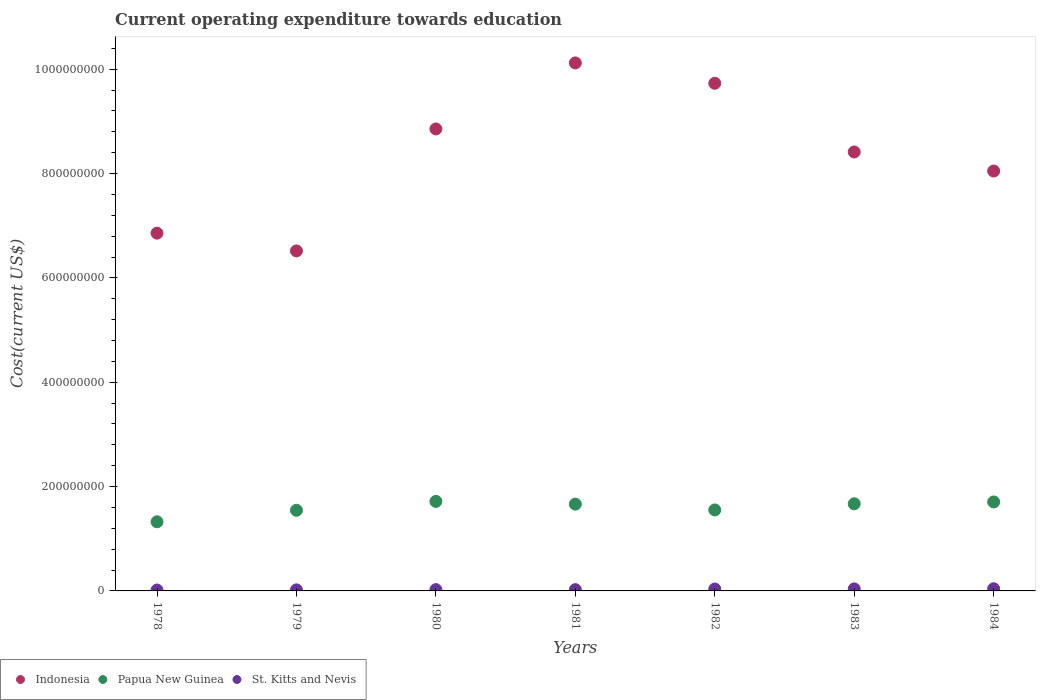Is the number of dotlines equal to the number of legend labels?
Give a very brief answer. Yes. What is the expenditure towards education in Papua New Guinea in 1981?
Your answer should be compact. 1.66e+08. Across all years, what is the maximum expenditure towards education in St. Kitts and Nevis?
Your answer should be very brief. 4.14e+06. Across all years, what is the minimum expenditure towards education in Indonesia?
Your answer should be compact. 6.52e+08. In which year was the expenditure towards education in Indonesia minimum?
Offer a terse response. 1979. What is the total expenditure towards education in St. Kitts and Nevis in the graph?
Make the answer very short. 2.03e+07. What is the difference between the expenditure towards education in Indonesia in 1980 and that in 1981?
Offer a very short reply. -1.27e+08. What is the difference between the expenditure towards education in Indonesia in 1981 and the expenditure towards education in Papua New Guinea in 1980?
Offer a very short reply. 8.40e+08. What is the average expenditure towards education in St. Kitts and Nevis per year?
Offer a very short reply. 2.90e+06. In the year 1980, what is the difference between the expenditure towards education in Papua New Guinea and expenditure towards education in Indonesia?
Give a very brief answer. -7.14e+08. In how many years, is the expenditure towards education in Papua New Guinea greater than 920000000 US$?
Offer a terse response. 0. What is the ratio of the expenditure towards education in St. Kitts and Nevis in 1980 to that in 1982?
Provide a succinct answer. 0.67. What is the difference between the highest and the second highest expenditure towards education in St. Kitts and Nevis?
Provide a short and direct response. 2.55e+05. What is the difference between the highest and the lowest expenditure towards education in Papua New Guinea?
Offer a very short reply. 3.90e+07. Is the sum of the expenditure towards education in St. Kitts and Nevis in 1980 and 1982 greater than the maximum expenditure towards education in Papua New Guinea across all years?
Offer a very short reply. No. Is it the case that in every year, the sum of the expenditure towards education in Papua New Guinea and expenditure towards education in St. Kitts and Nevis  is greater than the expenditure towards education in Indonesia?
Your response must be concise. No. Is the expenditure towards education in Indonesia strictly less than the expenditure towards education in Papua New Guinea over the years?
Provide a short and direct response. No. How many years are there in the graph?
Keep it short and to the point. 7. How are the legend labels stacked?
Offer a very short reply. Horizontal. What is the title of the graph?
Your response must be concise. Current operating expenditure towards education. Does "Cayman Islands" appear as one of the legend labels in the graph?
Give a very brief answer. No. What is the label or title of the Y-axis?
Keep it short and to the point. Cost(current US$). What is the Cost(current US$) in Indonesia in 1978?
Give a very brief answer. 6.86e+08. What is the Cost(current US$) in Papua New Guinea in 1978?
Offer a terse response. 1.33e+08. What is the Cost(current US$) of St. Kitts and Nevis in 1978?
Give a very brief answer. 1.71e+06. What is the Cost(current US$) in Indonesia in 1979?
Offer a very short reply. 6.52e+08. What is the Cost(current US$) of Papua New Guinea in 1979?
Give a very brief answer. 1.55e+08. What is the Cost(current US$) in St. Kitts and Nevis in 1979?
Keep it short and to the point. 2.01e+06. What is the Cost(current US$) in Indonesia in 1980?
Offer a terse response. 8.85e+08. What is the Cost(current US$) in Papua New Guinea in 1980?
Make the answer very short. 1.72e+08. What is the Cost(current US$) in St. Kitts and Nevis in 1980?
Keep it short and to the point. 2.43e+06. What is the Cost(current US$) in Indonesia in 1981?
Offer a very short reply. 1.01e+09. What is the Cost(current US$) in Papua New Guinea in 1981?
Offer a very short reply. 1.66e+08. What is the Cost(current US$) in St. Kitts and Nevis in 1981?
Make the answer very short. 2.47e+06. What is the Cost(current US$) in Indonesia in 1982?
Make the answer very short. 9.73e+08. What is the Cost(current US$) in Papua New Guinea in 1982?
Provide a succinct answer. 1.55e+08. What is the Cost(current US$) of St. Kitts and Nevis in 1982?
Keep it short and to the point. 3.64e+06. What is the Cost(current US$) in Indonesia in 1983?
Provide a succinct answer. 8.41e+08. What is the Cost(current US$) in Papua New Guinea in 1983?
Offer a very short reply. 1.67e+08. What is the Cost(current US$) of St. Kitts and Nevis in 1983?
Offer a terse response. 3.88e+06. What is the Cost(current US$) of Indonesia in 1984?
Give a very brief answer. 8.05e+08. What is the Cost(current US$) of Papua New Guinea in 1984?
Your answer should be compact. 1.71e+08. What is the Cost(current US$) of St. Kitts and Nevis in 1984?
Give a very brief answer. 4.14e+06. Across all years, what is the maximum Cost(current US$) in Indonesia?
Your answer should be compact. 1.01e+09. Across all years, what is the maximum Cost(current US$) in Papua New Guinea?
Make the answer very short. 1.72e+08. Across all years, what is the maximum Cost(current US$) of St. Kitts and Nevis?
Provide a succinct answer. 4.14e+06. Across all years, what is the minimum Cost(current US$) of Indonesia?
Offer a terse response. 6.52e+08. Across all years, what is the minimum Cost(current US$) of Papua New Guinea?
Give a very brief answer. 1.33e+08. Across all years, what is the minimum Cost(current US$) in St. Kitts and Nevis?
Offer a very short reply. 1.71e+06. What is the total Cost(current US$) of Indonesia in the graph?
Offer a terse response. 5.85e+09. What is the total Cost(current US$) in Papua New Guinea in the graph?
Give a very brief answer. 1.12e+09. What is the total Cost(current US$) in St. Kitts and Nevis in the graph?
Ensure brevity in your answer.  2.03e+07. What is the difference between the Cost(current US$) in Indonesia in 1978 and that in 1979?
Make the answer very short. 3.40e+07. What is the difference between the Cost(current US$) of Papua New Guinea in 1978 and that in 1979?
Ensure brevity in your answer.  -2.21e+07. What is the difference between the Cost(current US$) in St. Kitts and Nevis in 1978 and that in 1979?
Make the answer very short. -2.93e+05. What is the difference between the Cost(current US$) of Indonesia in 1978 and that in 1980?
Keep it short and to the point. -2.00e+08. What is the difference between the Cost(current US$) in Papua New Guinea in 1978 and that in 1980?
Provide a short and direct response. -3.90e+07. What is the difference between the Cost(current US$) of St. Kitts and Nevis in 1978 and that in 1980?
Make the answer very short. -7.20e+05. What is the difference between the Cost(current US$) in Indonesia in 1978 and that in 1981?
Keep it short and to the point. -3.26e+08. What is the difference between the Cost(current US$) of Papua New Guinea in 1978 and that in 1981?
Your answer should be compact. -3.38e+07. What is the difference between the Cost(current US$) in St. Kitts and Nevis in 1978 and that in 1981?
Offer a terse response. -7.57e+05. What is the difference between the Cost(current US$) in Indonesia in 1978 and that in 1982?
Offer a terse response. -2.87e+08. What is the difference between the Cost(current US$) of Papua New Guinea in 1978 and that in 1982?
Offer a terse response. -2.27e+07. What is the difference between the Cost(current US$) in St. Kitts and Nevis in 1978 and that in 1982?
Make the answer very short. -1.92e+06. What is the difference between the Cost(current US$) in Indonesia in 1978 and that in 1983?
Offer a very short reply. -1.56e+08. What is the difference between the Cost(current US$) in Papua New Guinea in 1978 and that in 1983?
Keep it short and to the point. -3.44e+07. What is the difference between the Cost(current US$) of St. Kitts and Nevis in 1978 and that in 1983?
Offer a very short reply. -2.17e+06. What is the difference between the Cost(current US$) in Indonesia in 1978 and that in 1984?
Offer a very short reply. -1.19e+08. What is the difference between the Cost(current US$) of Papua New Guinea in 1978 and that in 1984?
Your answer should be compact. -3.80e+07. What is the difference between the Cost(current US$) in St. Kitts and Nevis in 1978 and that in 1984?
Give a very brief answer. -2.42e+06. What is the difference between the Cost(current US$) in Indonesia in 1979 and that in 1980?
Give a very brief answer. -2.34e+08. What is the difference between the Cost(current US$) in Papua New Guinea in 1979 and that in 1980?
Offer a terse response. -1.70e+07. What is the difference between the Cost(current US$) of St. Kitts and Nevis in 1979 and that in 1980?
Give a very brief answer. -4.27e+05. What is the difference between the Cost(current US$) in Indonesia in 1979 and that in 1981?
Give a very brief answer. -3.60e+08. What is the difference between the Cost(current US$) in Papua New Guinea in 1979 and that in 1981?
Your response must be concise. -1.18e+07. What is the difference between the Cost(current US$) of St. Kitts and Nevis in 1979 and that in 1981?
Offer a terse response. -4.64e+05. What is the difference between the Cost(current US$) in Indonesia in 1979 and that in 1982?
Ensure brevity in your answer.  -3.21e+08. What is the difference between the Cost(current US$) of Papua New Guinea in 1979 and that in 1982?
Provide a succinct answer. -6.25e+05. What is the difference between the Cost(current US$) in St. Kitts and Nevis in 1979 and that in 1982?
Provide a short and direct response. -1.63e+06. What is the difference between the Cost(current US$) in Indonesia in 1979 and that in 1983?
Provide a short and direct response. -1.90e+08. What is the difference between the Cost(current US$) of Papua New Guinea in 1979 and that in 1983?
Provide a succinct answer. -1.24e+07. What is the difference between the Cost(current US$) in St. Kitts and Nevis in 1979 and that in 1983?
Your answer should be compact. -1.88e+06. What is the difference between the Cost(current US$) in Indonesia in 1979 and that in 1984?
Your answer should be compact. -1.53e+08. What is the difference between the Cost(current US$) of Papua New Guinea in 1979 and that in 1984?
Your answer should be very brief. -1.60e+07. What is the difference between the Cost(current US$) of St. Kitts and Nevis in 1979 and that in 1984?
Ensure brevity in your answer.  -2.13e+06. What is the difference between the Cost(current US$) of Indonesia in 1980 and that in 1981?
Your response must be concise. -1.27e+08. What is the difference between the Cost(current US$) in Papua New Guinea in 1980 and that in 1981?
Your response must be concise. 5.20e+06. What is the difference between the Cost(current US$) of St. Kitts and Nevis in 1980 and that in 1981?
Provide a short and direct response. -3.70e+04. What is the difference between the Cost(current US$) in Indonesia in 1980 and that in 1982?
Your answer should be compact. -8.75e+07. What is the difference between the Cost(current US$) in Papua New Guinea in 1980 and that in 1982?
Keep it short and to the point. 1.63e+07. What is the difference between the Cost(current US$) of St. Kitts and Nevis in 1980 and that in 1982?
Your response must be concise. -1.20e+06. What is the difference between the Cost(current US$) in Indonesia in 1980 and that in 1983?
Give a very brief answer. 4.41e+07. What is the difference between the Cost(current US$) in Papua New Guinea in 1980 and that in 1983?
Make the answer very short. 4.58e+06. What is the difference between the Cost(current US$) in St. Kitts and Nevis in 1980 and that in 1983?
Provide a short and direct response. -1.45e+06. What is the difference between the Cost(current US$) in Indonesia in 1980 and that in 1984?
Make the answer very short. 8.07e+07. What is the difference between the Cost(current US$) of Papua New Guinea in 1980 and that in 1984?
Your answer should be compact. 1.01e+06. What is the difference between the Cost(current US$) in St. Kitts and Nevis in 1980 and that in 1984?
Make the answer very short. -1.70e+06. What is the difference between the Cost(current US$) in Indonesia in 1981 and that in 1982?
Ensure brevity in your answer.  3.90e+07. What is the difference between the Cost(current US$) in Papua New Guinea in 1981 and that in 1982?
Offer a terse response. 1.11e+07. What is the difference between the Cost(current US$) in St. Kitts and Nevis in 1981 and that in 1982?
Provide a succinct answer. -1.17e+06. What is the difference between the Cost(current US$) in Indonesia in 1981 and that in 1983?
Provide a short and direct response. 1.71e+08. What is the difference between the Cost(current US$) in Papua New Guinea in 1981 and that in 1983?
Your response must be concise. -6.18e+05. What is the difference between the Cost(current US$) in St. Kitts and Nevis in 1981 and that in 1983?
Keep it short and to the point. -1.41e+06. What is the difference between the Cost(current US$) in Indonesia in 1981 and that in 1984?
Offer a terse response. 2.07e+08. What is the difference between the Cost(current US$) in Papua New Guinea in 1981 and that in 1984?
Your answer should be very brief. -4.19e+06. What is the difference between the Cost(current US$) of St. Kitts and Nevis in 1981 and that in 1984?
Offer a terse response. -1.67e+06. What is the difference between the Cost(current US$) of Indonesia in 1982 and that in 1983?
Make the answer very short. 1.32e+08. What is the difference between the Cost(current US$) in Papua New Guinea in 1982 and that in 1983?
Offer a terse response. -1.18e+07. What is the difference between the Cost(current US$) of St. Kitts and Nevis in 1982 and that in 1983?
Ensure brevity in your answer.  -2.45e+05. What is the difference between the Cost(current US$) of Indonesia in 1982 and that in 1984?
Provide a succinct answer. 1.68e+08. What is the difference between the Cost(current US$) in Papua New Guinea in 1982 and that in 1984?
Your response must be concise. -1.53e+07. What is the difference between the Cost(current US$) of St. Kitts and Nevis in 1982 and that in 1984?
Give a very brief answer. -5.01e+05. What is the difference between the Cost(current US$) in Indonesia in 1983 and that in 1984?
Keep it short and to the point. 3.65e+07. What is the difference between the Cost(current US$) in Papua New Guinea in 1983 and that in 1984?
Provide a succinct answer. -3.57e+06. What is the difference between the Cost(current US$) in St. Kitts and Nevis in 1983 and that in 1984?
Offer a very short reply. -2.55e+05. What is the difference between the Cost(current US$) in Indonesia in 1978 and the Cost(current US$) in Papua New Guinea in 1979?
Your response must be concise. 5.31e+08. What is the difference between the Cost(current US$) in Indonesia in 1978 and the Cost(current US$) in St. Kitts and Nevis in 1979?
Offer a terse response. 6.84e+08. What is the difference between the Cost(current US$) in Papua New Guinea in 1978 and the Cost(current US$) in St. Kitts and Nevis in 1979?
Your response must be concise. 1.31e+08. What is the difference between the Cost(current US$) in Indonesia in 1978 and the Cost(current US$) in Papua New Guinea in 1980?
Offer a very short reply. 5.14e+08. What is the difference between the Cost(current US$) in Indonesia in 1978 and the Cost(current US$) in St. Kitts and Nevis in 1980?
Offer a very short reply. 6.83e+08. What is the difference between the Cost(current US$) in Papua New Guinea in 1978 and the Cost(current US$) in St. Kitts and Nevis in 1980?
Offer a very short reply. 1.30e+08. What is the difference between the Cost(current US$) of Indonesia in 1978 and the Cost(current US$) of Papua New Guinea in 1981?
Offer a terse response. 5.19e+08. What is the difference between the Cost(current US$) in Indonesia in 1978 and the Cost(current US$) in St. Kitts and Nevis in 1981?
Offer a very short reply. 6.83e+08. What is the difference between the Cost(current US$) of Papua New Guinea in 1978 and the Cost(current US$) of St. Kitts and Nevis in 1981?
Your answer should be very brief. 1.30e+08. What is the difference between the Cost(current US$) of Indonesia in 1978 and the Cost(current US$) of Papua New Guinea in 1982?
Offer a terse response. 5.31e+08. What is the difference between the Cost(current US$) in Indonesia in 1978 and the Cost(current US$) in St. Kitts and Nevis in 1982?
Keep it short and to the point. 6.82e+08. What is the difference between the Cost(current US$) of Papua New Guinea in 1978 and the Cost(current US$) of St. Kitts and Nevis in 1982?
Provide a short and direct response. 1.29e+08. What is the difference between the Cost(current US$) in Indonesia in 1978 and the Cost(current US$) in Papua New Guinea in 1983?
Give a very brief answer. 5.19e+08. What is the difference between the Cost(current US$) of Indonesia in 1978 and the Cost(current US$) of St. Kitts and Nevis in 1983?
Provide a short and direct response. 6.82e+08. What is the difference between the Cost(current US$) in Papua New Guinea in 1978 and the Cost(current US$) in St. Kitts and Nevis in 1983?
Offer a very short reply. 1.29e+08. What is the difference between the Cost(current US$) of Indonesia in 1978 and the Cost(current US$) of Papua New Guinea in 1984?
Give a very brief answer. 5.15e+08. What is the difference between the Cost(current US$) in Indonesia in 1978 and the Cost(current US$) in St. Kitts and Nevis in 1984?
Your response must be concise. 6.82e+08. What is the difference between the Cost(current US$) of Papua New Guinea in 1978 and the Cost(current US$) of St. Kitts and Nevis in 1984?
Provide a short and direct response. 1.28e+08. What is the difference between the Cost(current US$) of Indonesia in 1979 and the Cost(current US$) of Papua New Guinea in 1980?
Your answer should be very brief. 4.80e+08. What is the difference between the Cost(current US$) in Indonesia in 1979 and the Cost(current US$) in St. Kitts and Nevis in 1980?
Provide a short and direct response. 6.49e+08. What is the difference between the Cost(current US$) of Papua New Guinea in 1979 and the Cost(current US$) of St. Kitts and Nevis in 1980?
Provide a short and direct response. 1.52e+08. What is the difference between the Cost(current US$) of Indonesia in 1979 and the Cost(current US$) of Papua New Guinea in 1981?
Your answer should be compact. 4.85e+08. What is the difference between the Cost(current US$) in Indonesia in 1979 and the Cost(current US$) in St. Kitts and Nevis in 1981?
Give a very brief answer. 6.49e+08. What is the difference between the Cost(current US$) in Papua New Guinea in 1979 and the Cost(current US$) in St. Kitts and Nevis in 1981?
Offer a terse response. 1.52e+08. What is the difference between the Cost(current US$) of Indonesia in 1979 and the Cost(current US$) of Papua New Guinea in 1982?
Keep it short and to the point. 4.97e+08. What is the difference between the Cost(current US$) of Indonesia in 1979 and the Cost(current US$) of St. Kitts and Nevis in 1982?
Make the answer very short. 6.48e+08. What is the difference between the Cost(current US$) in Papua New Guinea in 1979 and the Cost(current US$) in St. Kitts and Nevis in 1982?
Provide a short and direct response. 1.51e+08. What is the difference between the Cost(current US$) of Indonesia in 1979 and the Cost(current US$) of Papua New Guinea in 1983?
Offer a terse response. 4.85e+08. What is the difference between the Cost(current US$) in Indonesia in 1979 and the Cost(current US$) in St. Kitts and Nevis in 1983?
Offer a terse response. 6.48e+08. What is the difference between the Cost(current US$) in Papua New Guinea in 1979 and the Cost(current US$) in St. Kitts and Nevis in 1983?
Offer a very short reply. 1.51e+08. What is the difference between the Cost(current US$) in Indonesia in 1979 and the Cost(current US$) in Papua New Guinea in 1984?
Ensure brevity in your answer.  4.81e+08. What is the difference between the Cost(current US$) of Indonesia in 1979 and the Cost(current US$) of St. Kitts and Nevis in 1984?
Your response must be concise. 6.48e+08. What is the difference between the Cost(current US$) in Papua New Guinea in 1979 and the Cost(current US$) in St. Kitts and Nevis in 1984?
Your response must be concise. 1.50e+08. What is the difference between the Cost(current US$) in Indonesia in 1980 and the Cost(current US$) in Papua New Guinea in 1981?
Offer a terse response. 7.19e+08. What is the difference between the Cost(current US$) in Indonesia in 1980 and the Cost(current US$) in St. Kitts and Nevis in 1981?
Ensure brevity in your answer.  8.83e+08. What is the difference between the Cost(current US$) in Papua New Guinea in 1980 and the Cost(current US$) in St. Kitts and Nevis in 1981?
Provide a short and direct response. 1.69e+08. What is the difference between the Cost(current US$) of Indonesia in 1980 and the Cost(current US$) of Papua New Guinea in 1982?
Ensure brevity in your answer.  7.30e+08. What is the difference between the Cost(current US$) of Indonesia in 1980 and the Cost(current US$) of St. Kitts and Nevis in 1982?
Make the answer very short. 8.82e+08. What is the difference between the Cost(current US$) of Papua New Guinea in 1980 and the Cost(current US$) of St. Kitts and Nevis in 1982?
Offer a very short reply. 1.68e+08. What is the difference between the Cost(current US$) of Indonesia in 1980 and the Cost(current US$) of Papua New Guinea in 1983?
Your answer should be compact. 7.18e+08. What is the difference between the Cost(current US$) of Indonesia in 1980 and the Cost(current US$) of St. Kitts and Nevis in 1983?
Your answer should be very brief. 8.82e+08. What is the difference between the Cost(current US$) in Papua New Guinea in 1980 and the Cost(current US$) in St. Kitts and Nevis in 1983?
Keep it short and to the point. 1.68e+08. What is the difference between the Cost(current US$) in Indonesia in 1980 and the Cost(current US$) in Papua New Guinea in 1984?
Your answer should be very brief. 7.15e+08. What is the difference between the Cost(current US$) in Indonesia in 1980 and the Cost(current US$) in St. Kitts and Nevis in 1984?
Offer a terse response. 8.81e+08. What is the difference between the Cost(current US$) of Papua New Guinea in 1980 and the Cost(current US$) of St. Kitts and Nevis in 1984?
Your answer should be very brief. 1.67e+08. What is the difference between the Cost(current US$) in Indonesia in 1981 and the Cost(current US$) in Papua New Guinea in 1982?
Provide a succinct answer. 8.57e+08. What is the difference between the Cost(current US$) of Indonesia in 1981 and the Cost(current US$) of St. Kitts and Nevis in 1982?
Ensure brevity in your answer.  1.01e+09. What is the difference between the Cost(current US$) of Papua New Guinea in 1981 and the Cost(current US$) of St. Kitts and Nevis in 1982?
Provide a succinct answer. 1.63e+08. What is the difference between the Cost(current US$) of Indonesia in 1981 and the Cost(current US$) of Papua New Guinea in 1983?
Ensure brevity in your answer.  8.45e+08. What is the difference between the Cost(current US$) of Indonesia in 1981 and the Cost(current US$) of St. Kitts and Nevis in 1983?
Offer a terse response. 1.01e+09. What is the difference between the Cost(current US$) of Papua New Guinea in 1981 and the Cost(current US$) of St. Kitts and Nevis in 1983?
Your answer should be compact. 1.62e+08. What is the difference between the Cost(current US$) of Indonesia in 1981 and the Cost(current US$) of Papua New Guinea in 1984?
Provide a short and direct response. 8.41e+08. What is the difference between the Cost(current US$) in Indonesia in 1981 and the Cost(current US$) in St. Kitts and Nevis in 1984?
Keep it short and to the point. 1.01e+09. What is the difference between the Cost(current US$) of Papua New Guinea in 1981 and the Cost(current US$) of St. Kitts and Nevis in 1984?
Make the answer very short. 1.62e+08. What is the difference between the Cost(current US$) in Indonesia in 1982 and the Cost(current US$) in Papua New Guinea in 1983?
Your response must be concise. 8.06e+08. What is the difference between the Cost(current US$) in Indonesia in 1982 and the Cost(current US$) in St. Kitts and Nevis in 1983?
Make the answer very short. 9.69e+08. What is the difference between the Cost(current US$) in Papua New Guinea in 1982 and the Cost(current US$) in St. Kitts and Nevis in 1983?
Keep it short and to the point. 1.51e+08. What is the difference between the Cost(current US$) in Indonesia in 1982 and the Cost(current US$) in Papua New Guinea in 1984?
Your answer should be compact. 8.02e+08. What is the difference between the Cost(current US$) in Indonesia in 1982 and the Cost(current US$) in St. Kitts and Nevis in 1984?
Keep it short and to the point. 9.69e+08. What is the difference between the Cost(current US$) in Papua New Guinea in 1982 and the Cost(current US$) in St. Kitts and Nevis in 1984?
Keep it short and to the point. 1.51e+08. What is the difference between the Cost(current US$) in Indonesia in 1983 and the Cost(current US$) in Papua New Guinea in 1984?
Provide a succinct answer. 6.71e+08. What is the difference between the Cost(current US$) of Indonesia in 1983 and the Cost(current US$) of St. Kitts and Nevis in 1984?
Offer a very short reply. 8.37e+08. What is the difference between the Cost(current US$) in Papua New Guinea in 1983 and the Cost(current US$) in St. Kitts and Nevis in 1984?
Offer a terse response. 1.63e+08. What is the average Cost(current US$) of Indonesia per year?
Keep it short and to the point. 8.36e+08. What is the average Cost(current US$) of Papua New Guinea per year?
Ensure brevity in your answer.  1.60e+08. What is the average Cost(current US$) of St. Kitts and Nevis per year?
Keep it short and to the point. 2.90e+06. In the year 1978, what is the difference between the Cost(current US$) of Indonesia and Cost(current US$) of Papua New Guinea?
Offer a terse response. 5.53e+08. In the year 1978, what is the difference between the Cost(current US$) in Indonesia and Cost(current US$) in St. Kitts and Nevis?
Give a very brief answer. 6.84e+08. In the year 1978, what is the difference between the Cost(current US$) in Papua New Guinea and Cost(current US$) in St. Kitts and Nevis?
Give a very brief answer. 1.31e+08. In the year 1979, what is the difference between the Cost(current US$) in Indonesia and Cost(current US$) in Papua New Guinea?
Your answer should be compact. 4.97e+08. In the year 1979, what is the difference between the Cost(current US$) of Indonesia and Cost(current US$) of St. Kitts and Nevis?
Make the answer very short. 6.50e+08. In the year 1979, what is the difference between the Cost(current US$) of Papua New Guinea and Cost(current US$) of St. Kitts and Nevis?
Ensure brevity in your answer.  1.53e+08. In the year 1980, what is the difference between the Cost(current US$) in Indonesia and Cost(current US$) in Papua New Guinea?
Make the answer very short. 7.14e+08. In the year 1980, what is the difference between the Cost(current US$) in Indonesia and Cost(current US$) in St. Kitts and Nevis?
Make the answer very short. 8.83e+08. In the year 1980, what is the difference between the Cost(current US$) of Papua New Guinea and Cost(current US$) of St. Kitts and Nevis?
Provide a succinct answer. 1.69e+08. In the year 1981, what is the difference between the Cost(current US$) in Indonesia and Cost(current US$) in Papua New Guinea?
Offer a terse response. 8.46e+08. In the year 1981, what is the difference between the Cost(current US$) of Indonesia and Cost(current US$) of St. Kitts and Nevis?
Keep it short and to the point. 1.01e+09. In the year 1981, what is the difference between the Cost(current US$) of Papua New Guinea and Cost(current US$) of St. Kitts and Nevis?
Make the answer very short. 1.64e+08. In the year 1982, what is the difference between the Cost(current US$) of Indonesia and Cost(current US$) of Papua New Guinea?
Give a very brief answer. 8.18e+08. In the year 1982, what is the difference between the Cost(current US$) in Indonesia and Cost(current US$) in St. Kitts and Nevis?
Provide a short and direct response. 9.69e+08. In the year 1982, what is the difference between the Cost(current US$) of Papua New Guinea and Cost(current US$) of St. Kitts and Nevis?
Your answer should be very brief. 1.52e+08. In the year 1983, what is the difference between the Cost(current US$) of Indonesia and Cost(current US$) of Papua New Guinea?
Offer a terse response. 6.74e+08. In the year 1983, what is the difference between the Cost(current US$) in Indonesia and Cost(current US$) in St. Kitts and Nevis?
Your answer should be compact. 8.37e+08. In the year 1983, what is the difference between the Cost(current US$) in Papua New Guinea and Cost(current US$) in St. Kitts and Nevis?
Give a very brief answer. 1.63e+08. In the year 1984, what is the difference between the Cost(current US$) in Indonesia and Cost(current US$) in Papua New Guinea?
Make the answer very short. 6.34e+08. In the year 1984, what is the difference between the Cost(current US$) of Indonesia and Cost(current US$) of St. Kitts and Nevis?
Provide a succinct answer. 8.01e+08. In the year 1984, what is the difference between the Cost(current US$) in Papua New Guinea and Cost(current US$) in St. Kitts and Nevis?
Your answer should be very brief. 1.66e+08. What is the ratio of the Cost(current US$) in Indonesia in 1978 to that in 1979?
Keep it short and to the point. 1.05. What is the ratio of the Cost(current US$) of Papua New Guinea in 1978 to that in 1979?
Provide a succinct answer. 0.86. What is the ratio of the Cost(current US$) in St. Kitts and Nevis in 1978 to that in 1979?
Your response must be concise. 0.85. What is the ratio of the Cost(current US$) in Indonesia in 1978 to that in 1980?
Your response must be concise. 0.77. What is the ratio of the Cost(current US$) of Papua New Guinea in 1978 to that in 1980?
Make the answer very short. 0.77. What is the ratio of the Cost(current US$) in St. Kitts and Nevis in 1978 to that in 1980?
Keep it short and to the point. 0.7. What is the ratio of the Cost(current US$) in Indonesia in 1978 to that in 1981?
Offer a very short reply. 0.68. What is the ratio of the Cost(current US$) in Papua New Guinea in 1978 to that in 1981?
Keep it short and to the point. 0.8. What is the ratio of the Cost(current US$) of St. Kitts and Nevis in 1978 to that in 1981?
Keep it short and to the point. 0.69. What is the ratio of the Cost(current US$) of Indonesia in 1978 to that in 1982?
Provide a succinct answer. 0.7. What is the ratio of the Cost(current US$) of Papua New Guinea in 1978 to that in 1982?
Give a very brief answer. 0.85. What is the ratio of the Cost(current US$) in St. Kitts and Nevis in 1978 to that in 1982?
Provide a succinct answer. 0.47. What is the ratio of the Cost(current US$) in Indonesia in 1978 to that in 1983?
Your answer should be very brief. 0.82. What is the ratio of the Cost(current US$) in Papua New Guinea in 1978 to that in 1983?
Offer a terse response. 0.79. What is the ratio of the Cost(current US$) in St. Kitts and Nevis in 1978 to that in 1983?
Ensure brevity in your answer.  0.44. What is the ratio of the Cost(current US$) of Indonesia in 1978 to that in 1984?
Give a very brief answer. 0.85. What is the ratio of the Cost(current US$) in Papua New Guinea in 1978 to that in 1984?
Your answer should be very brief. 0.78. What is the ratio of the Cost(current US$) in St. Kitts and Nevis in 1978 to that in 1984?
Give a very brief answer. 0.41. What is the ratio of the Cost(current US$) of Indonesia in 1979 to that in 1980?
Give a very brief answer. 0.74. What is the ratio of the Cost(current US$) of Papua New Guinea in 1979 to that in 1980?
Offer a very short reply. 0.9. What is the ratio of the Cost(current US$) of St. Kitts and Nevis in 1979 to that in 1980?
Provide a succinct answer. 0.82. What is the ratio of the Cost(current US$) in Indonesia in 1979 to that in 1981?
Make the answer very short. 0.64. What is the ratio of the Cost(current US$) in Papua New Guinea in 1979 to that in 1981?
Offer a very short reply. 0.93. What is the ratio of the Cost(current US$) in St. Kitts and Nevis in 1979 to that in 1981?
Provide a short and direct response. 0.81. What is the ratio of the Cost(current US$) in Indonesia in 1979 to that in 1982?
Offer a very short reply. 0.67. What is the ratio of the Cost(current US$) of St. Kitts and Nevis in 1979 to that in 1982?
Your answer should be very brief. 0.55. What is the ratio of the Cost(current US$) in Indonesia in 1979 to that in 1983?
Keep it short and to the point. 0.77. What is the ratio of the Cost(current US$) of Papua New Guinea in 1979 to that in 1983?
Give a very brief answer. 0.93. What is the ratio of the Cost(current US$) of St. Kitts and Nevis in 1979 to that in 1983?
Provide a succinct answer. 0.52. What is the ratio of the Cost(current US$) of Indonesia in 1979 to that in 1984?
Your response must be concise. 0.81. What is the ratio of the Cost(current US$) of Papua New Guinea in 1979 to that in 1984?
Your response must be concise. 0.91. What is the ratio of the Cost(current US$) in St. Kitts and Nevis in 1979 to that in 1984?
Provide a succinct answer. 0.48. What is the ratio of the Cost(current US$) in Papua New Guinea in 1980 to that in 1981?
Your response must be concise. 1.03. What is the ratio of the Cost(current US$) in St. Kitts and Nevis in 1980 to that in 1981?
Ensure brevity in your answer.  0.98. What is the ratio of the Cost(current US$) in Indonesia in 1980 to that in 1982?
Keep it short and to the point. 0.91. What is the ratio of the Cost(current US$) of Papua New Guinea in 1980 to that in 1982?
Provide a short and direct response. 1.11. What is the ratio of the Cost(current US$) in St. Kitts and Nevis in 1980 to that in 1982?
Keep it short and to the point. 0.67. What is the ratio of the Cost(current US$) in Indonesia in 1980 to that in 1983?
Your answer should be very brief. 1.05. What is the ratio of the Cost(current US$) in Papua New Guinea in 1980 to that in 1983?
Make the answer very short. 1.03. What is the ratio of the Cost(current US$) in St. Kitts and Nevis in 1980 to that in 1983?
Offer a very short reply. 0.63. What is the ratio of the Cost(current US$) of Indonesia in 1980 to that in 1984?
Your response must be concise. 1.1. What is the ratio of the Cost(current US$) of Papua New Guinea in 1980 to that in 1984?
Provide a succinct answer. 1.01. What is the ratio of the Cost(current US$) of St. Kitts and Nevis in 1980 to that in 1984?
Give a very brief answer. 0.59. What is the ratio of the Cost(current US$) in Indonesia in 1981 to that in 1982?
Your response must be concise. 1.04. What is the ratio of the Cost(current US$) in Papua New Guinea in 1981 to that in 1982?
Your answer should be compact. 1.07. What is the ratio of the Cost(current US$) of St. Kitts and Nevis in 1981 to that in 1982?
Ensure brevity in your answer.  0.68. What is the ratio of the Cost(current US$) of Indonesia in 1981 to that in 1983?
Your answer should be very brief. 1.2. What is the ratio of the Cost(current US$) of St. Kitts and Nevis in 1981 to that in 1983?
Provide a short and direct response. 0.64. What is the ratio of the Cost(current US$) in Indonesia in 1981 to that in 1984?
Offer a terse response. 1.26. What is the ratio of the Cost(current US$) of Papua New Guinea in 1981 to that in 1984?
Offer a terse response. 0.98. What is the ratio of the Cost(current US$) of St. Kitts and Nevis in 1981 to that in 1984?
Provide a short and direct response. 0.6. What is the ratio of the Cost(current US$) of Indonesia in 1982 to that in 1983?
Offer a very short reply. 1.16. What is the ratio of the Cost(current US$) of Papua New Guinea in 1982 to that in 1983?
Ensure brevity in your answer.  0.93. What is the ratio of the Cost(current US$) in St. Kitts and Nevis in 1982 to that in 1983?
Offer a terse response. 0.94. What is the ratio of the Cost(current US$) in Indonesia in 1982 to that in 1984?
Offer a very short reply. 1.21. What is the ratio of the Cost(current US$) in Papua New Guinea in 1982 to that in 1984?
Your answer should be very brief. 0.91. What is the ratio of the Cost(current US$) in St. Kitts and Nevis in 1982 to that in 1984?
Ensure brevity in your answer.  0.88. What is the ratio of the Cost(current US$) of Indonesia in 1983 to that in 1984?
Ensure brevity in your answer.  1.05. What is the ratio of the Cost(current US$) in Papua New Guinea in 1983 to that in 1984?
Make the answer very short. 0.98. What is the ratio of the Cost(current US$) in St. Kitts and Nevis in 1983 to that in 1984?
Offer a very short reply. 0.94. What is the difference between the highest and the second highest Cost(current US$) in Indonesia?
Offer a very short reply. 3.90e+07. What is the difference between the highest and the second highest Cost(current US$) of Papua New Guinea?
Offer a very short reply. 1.01e+06. What is the difference between the highest and the second highest Cost(current US$) in St. Kitts and Nevis?
Your answer should be compact. 2.55e+05. What is the difference between the highest and the lowest Cost(current US$) in Indonesia?
Provide a succinct answer. 3.60e+08. What is the difference between the highest and the lowest Cost(current US$) in Papua New Guinea?
Your answer should be very brief. 3.90e+07. What is the difference between the highest and the lowest Cost(current US$) of St. Kitts and Nevis?
Give a very brief answer. 2.42e+06. 